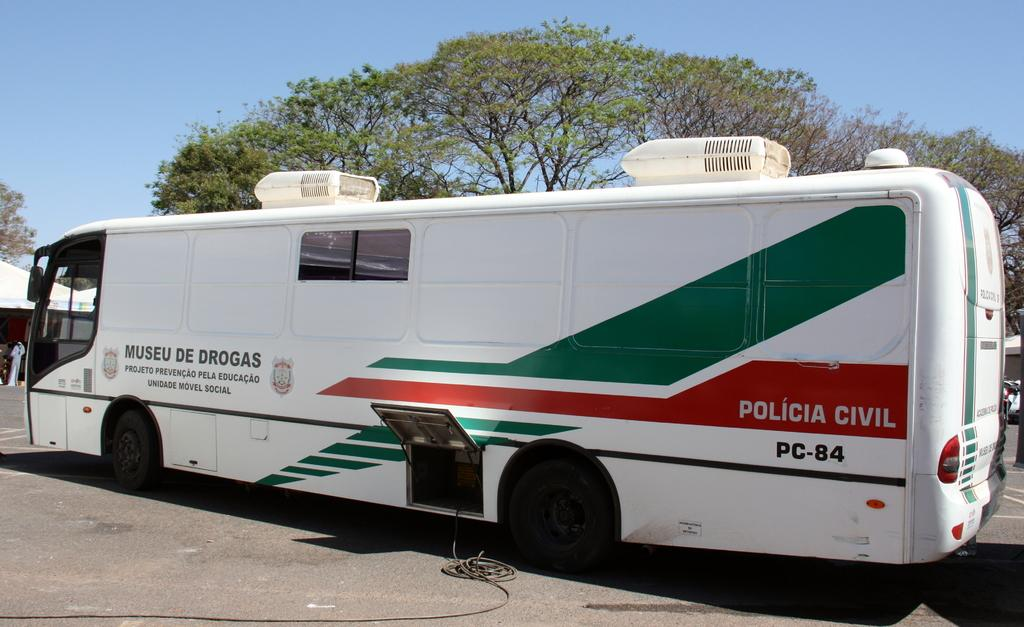<image>
Offer a succinct explanation of the picture presented. A large white bus is numbered PC-84 on the rear end of the driver's side. 